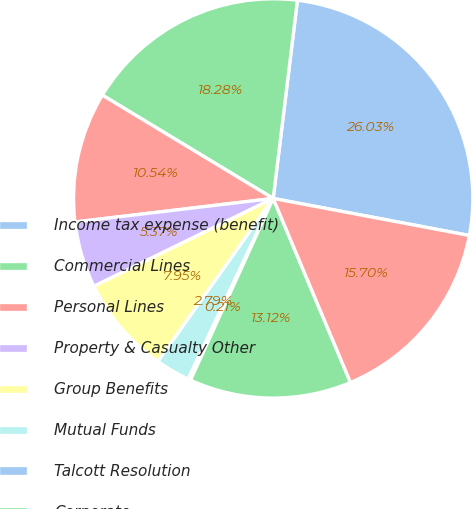Convert chart. <chart><loc_0><loc_0><loc_500><loc_500><pie_chart><fcel>Income tax expense (benefit)<fcel>Commercial Lines<fcel>Personal Lines<fcel>Property & Casualty Other<fcel>Group Benefits<fcel>Mutual Funds<fcel>Talcott Resolution<fcel>Corporate<fcel>Total income tax expense<nl><fcel>26.03%<fcel>18.28%<fcel>10.54%<fcel>5.37%<fcel>7.95%<fcel>2.79%<fcel>0.21%<fcel>13.12%<fcel>15.7%<nl></chart> 